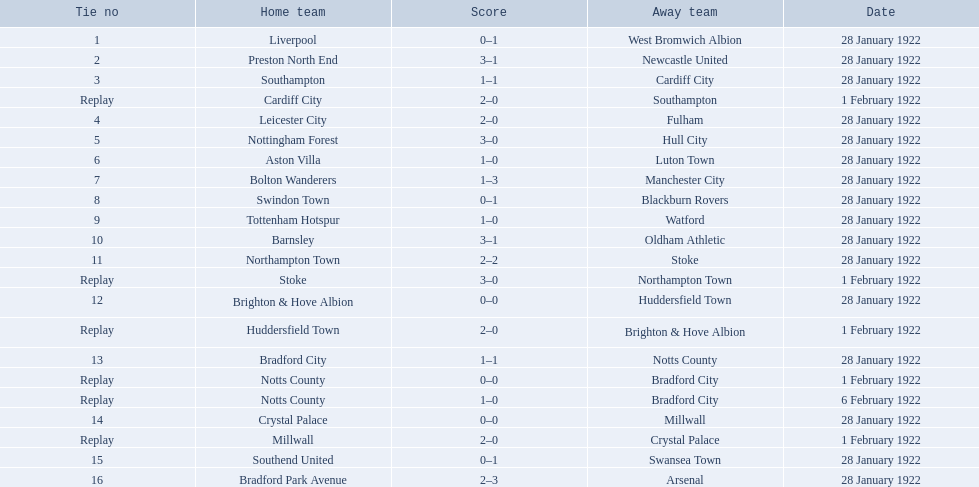What are all of the home teams? Liverpool, Preston North End, Southampton, Cardiff City, Leicester City, Nottingham Forest, Aston Villa, Bolton Wanderers, Swindon Town, Tottenham Hotspur, Barnsley, Northampton Town, Stoke, Brighton & Hove Albion, Huddersfield Town, Bradford City, Notts County, Notts County, Crystal Palace, Millwall, Southend United, Bradford Park Avenue. What were the scores? 0–1, 3–1, 1–1, 2–0, 2–0, 3–0, 1–0, 1–3, 0–1, 1–0, 3–1, 2–2, 3–0, 0–0, 2–0, 1–1, 0–0, 1–0, 0–0, 2–0, 0–1, 2–3. On which dates did they play? 28 January 1922, 28 January 1922, 28 January 1922, 1 February 1922, 28 January 1922, 28 January 1922, 28 January 1922, 28 January 1922, 28 January 1922, 28 January 1922, 28 January 1922, 28 January 1922, 1 February 1922, 28 January 1922, 1 February 1922, 28 January 1922, 1 February 1922, 6 February 1922, 28 January 1922, 1 February 1922, 28 January 1922, 28 January 1922. Which teams played on 28 january 1922? Liverpool, Preston North End, Southampton, Leicester City, Nottingham Forest, Aston Villa, Bolton Wanderers, Swindon Town, Tottenham Hotspur, Barnsley, Northampton Town, Brighton & Hove Albion, Bradford City, Crystal Palace, Southend United, Bradford Park Avenue. Of those, which scored the same as aston villa? Tottenham Hotspur. 